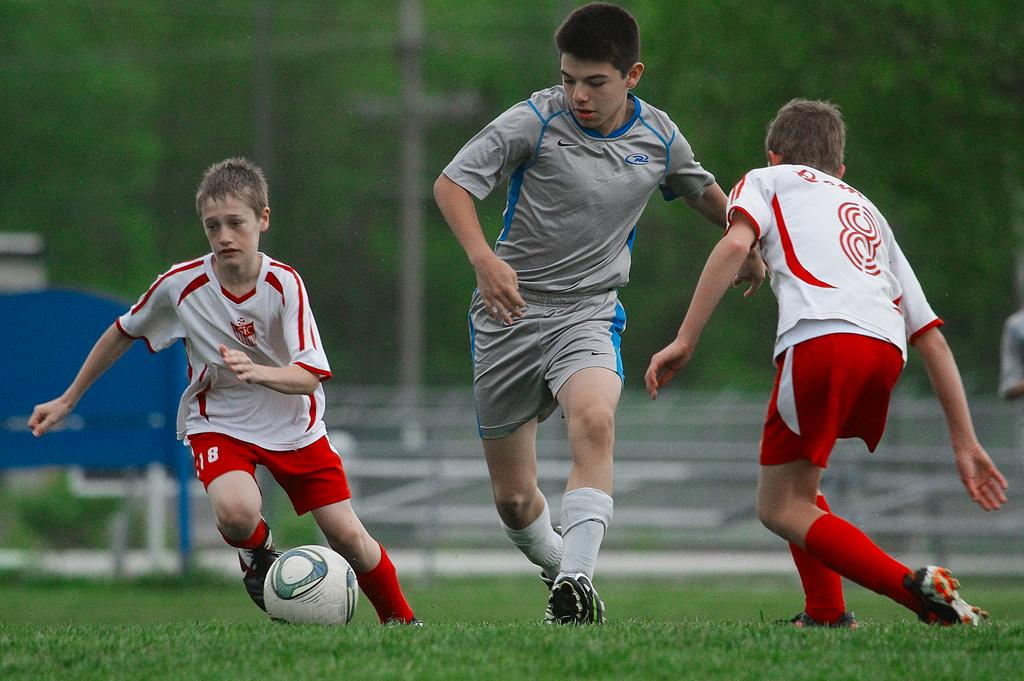Where was the image taken? The image was taken in a garden. How many boys are in the image? There are three boys in the image. What are the boys doing in the image? The boys are running and playing football. What object is on the grass in the image? There is a football on the grass. What can be seen in the background of the image? There are trees and a board in the background of the image. What type of coal can be seen in the image? There is no coal present in the image. How much does the goldfish weigh in the image? There is no goldfish present in the image. 